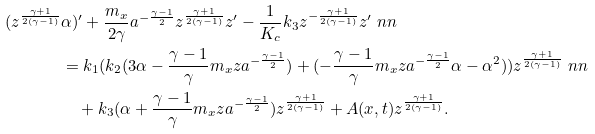Convert formula to latex. <formula><loc_0><loc_0><loc_500><loc_500>( z ^ { \frac { \gamma + 1 } { 2 ( \gamma - 1 ) } } & \alpha ) ^ { \prime } + \frac { m _ { x } } { 2 \gamma } a ^ { - \frac { \gamma - 1 } { 2 } } z ^ { \frac { \gamma + 1 } { 2 ( \gamma - 1 ) } } z ^ { \prime } - \frac { 1 } { K _ { c } } k _ { 3 } z ^ { - \frac { \gamma + 1 } { 2 ( \gamma - 1 ) } } z ^ { \prime } \ n n \\ & = k _ { 1 } ( k _ { 2 } ( 3 \alpha - { \frac { \gamma - 1 } { \gamma } } m _ { x } z a ^ { - \frac { \gamma - 1 } { 2 } } ) + ( - { \frac { \gamma - 1 } { \gamma } } m _ { x } z a ^ { - \frac { \gamma - 1 } { 2 } } \alpha - \alpha ^ { 2 } ) ) z ^ { \frac { \gamma + 1 } { 2 ( \gamma - 1 ) } } \ n n \\ & \quad + k _ { 3 } ( \alpha + { \frac { \gamma - 1 } { \gamma } } m _ { x } z a ^ { - \frac { \gamma - 1 } { 2 } } ) z ^ { \frac { \gamma + 1 } { 2 ( \gamma - 1 ) } } + A ( x , t ) z ^ { \frac { \gamma + 1 } { 2 ( \gamma - 1 ) } } .</formula> 